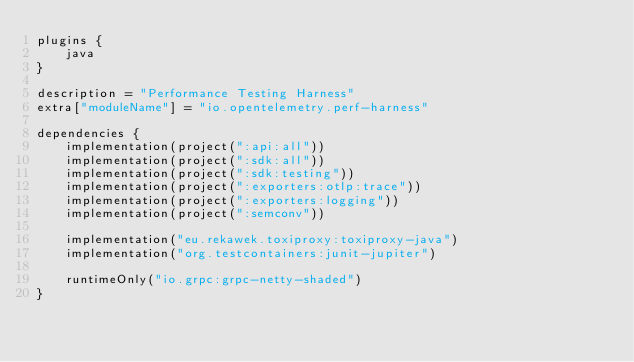Convert code to text. <code><loc_0><loc_0><loc_500><loc_500><_Kotlin_>plugins {
    java
}

description = "Performance Testing Harness"
extra["moduleName"] = "io.opentelemetry.perf-harness"

dependencies {
    implementation(project(":api:all"))
    implementation(project(":sdk:all"))
    implementation(project(":sdk:testing"))
    implementation(project(":exporters:otlp:trace"))
    implementation(project(":exporters:logging"))
    implementation(project(":semconv"))

    implementation("eu.rekawek.toxiproxy:toxiproxy-java")
    implementation("org.testcontainers:junit-jupiter")

    runtimeOnly("io.grpc:grpc-netty-shaded")
}
</code> 